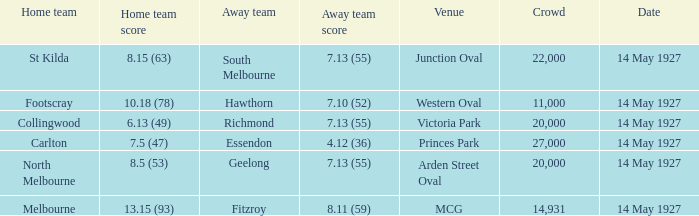Which site featured a home team with a score of 1 MCG. 